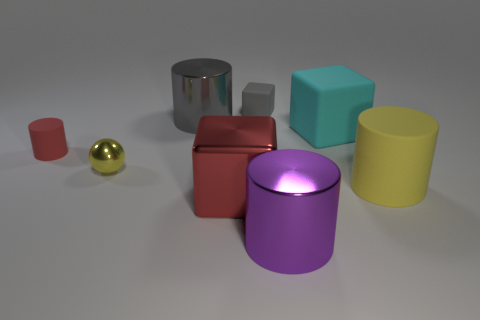Subtract all big purple cylinders. How many cylinders are left? 3 Add 1 gray metal cylinders. How many objects exist? 9 Subtract all red blocks. How many blocks are left? 2 Subtract all cubes. How many objects are left? 5 Subtract 1 cylinders. How many cylinders are left? 3 Add 3 purple objects. How many purple objects are left? 4 Add 6 cyan rubber objects. How many cyan rubber objects exist? 7 Subtract 0 cyan cylinders. How many objects are left? 8 Subtract all red cubes. Subtract all brown cylinders. How many cubes are left? 2 Subtract all tiny green balls. Subtract all gray cylinders. How many objects are left? 7 